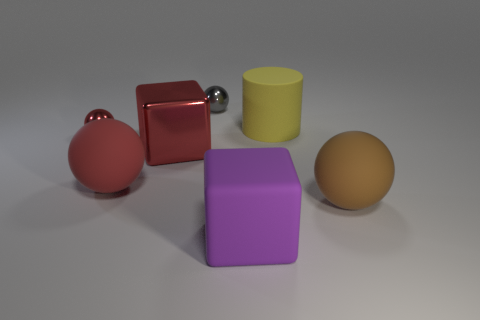Can you describe the contrast in shapes and colors presented in this image? Certainly! The image displays an intriguing array of geometric shapes: there's a sphere, cubes, and a cylinder. These shapes come in a variety of colors, including a vibrant red for both the sphere and cube, a soothing purple for the large block, a reflective silver for the small sphere, and an earthy tan for the other sphere. A muted yellow cylindrical shape adds to the diversity. This collection of shapes and colors seems to provide an exercise in visual comparison, highlighting the differences between round and angular forms, as well as the way specific colors and tints interact with light and shadow, creating a vivid contrast and a pleasing composition.  Could the arrangement of these objects tell us anything about spatial perception? Yes, indeed. The arrangement in the image can be explored to understand spatial perception. The positioning of the objects with respect to one another suggests depth. For example, the red cube and the red sphere appear closer to each other, creating the illusion that they are in the forefront. Meanwhile, the other shapes, like the purple block and the tan sphere, appear further away due to their placement and the shadows cast. This layout can be used to discuss concepts like perspective, the effect of lighting on objects, and how color and scale contribute to the perception of distance within a three-dimensional space. 